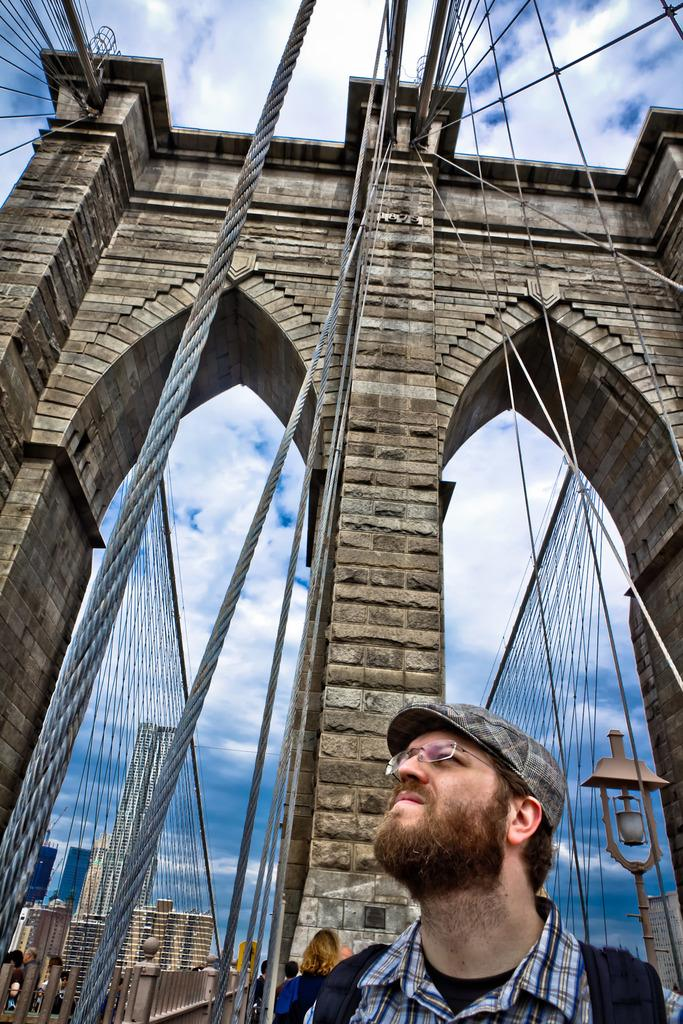Where is the man located in the image? The man is in the bottom right side of the image. What is the main subject of the image? The main subject of the image is a bridge construction. What can be seen in the background of the image? There are buildings in the background of the image. What is visible in the sky in the image? There are clouds in the sky. What type of throat lozenges can be seen in the image? There are no throat lozenges present in the image. Can you describe the carriage used by the construction workers in the image? There is no carriage or construction workers present in the image. 